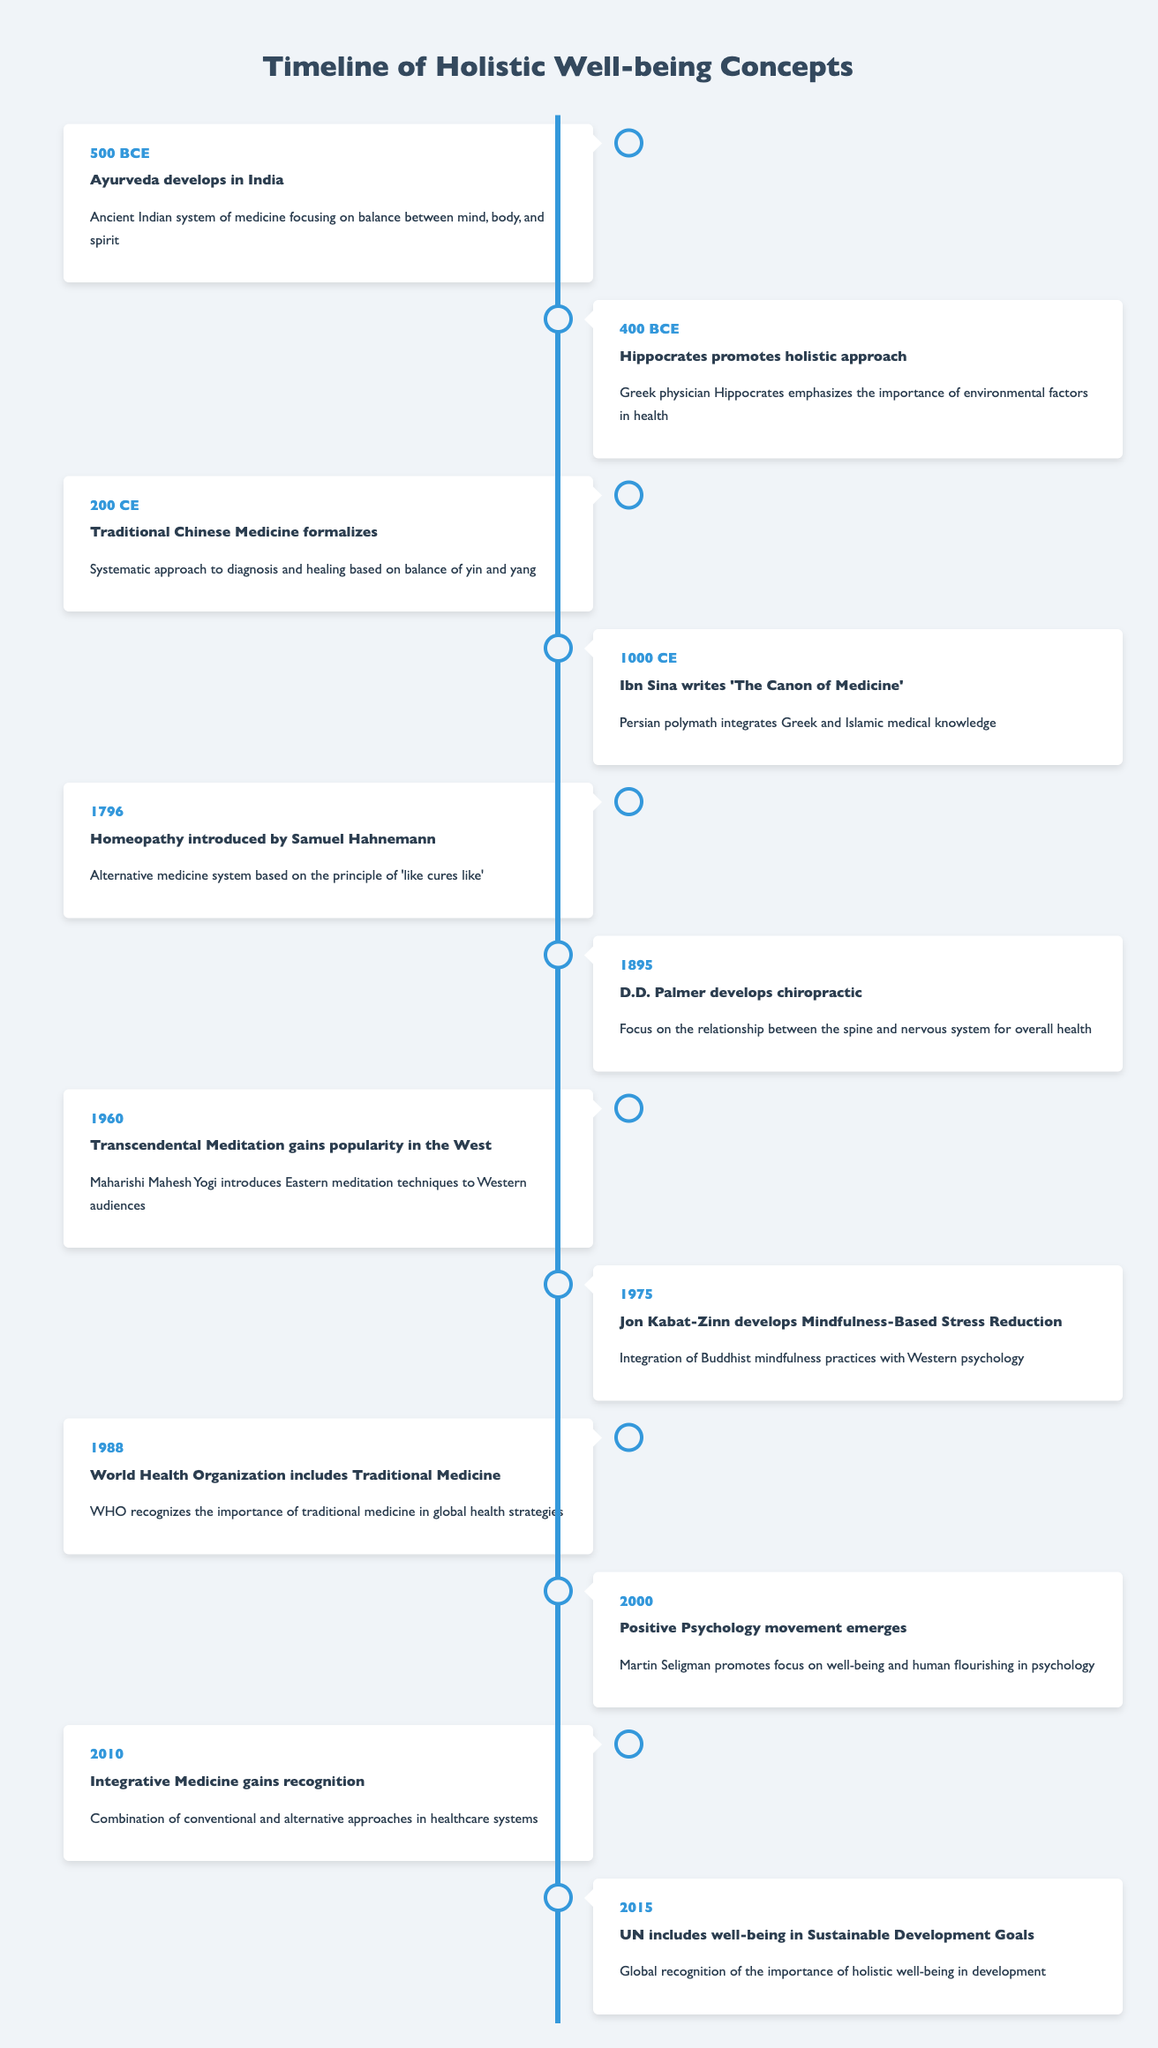What year did Ayurveda develop in India? According to the timeline, Ayurveda developed in India in the year 500 BCE.
Answer: 500 BCE Which philosophy did Hippocrates contribute to in 400 BCE? The timeline states that in 400 BCE, Hippocrates promoted a holistic approach, emphasizing the importance of environmental factors in health.
Answer: Holistic approach What is the event related to Traditional Chinese Medicine? The timeline indicates that Traditional Chinese Medicine was formalized in the year 200 CE.
Answer: 200 CE Which event occurred first: the introduction of Homeopathy or the development of Chiropractic? Homeopathy was introduced in 1796, while Chiropractic was developed in 1895. Since 1796 is earlier than 1895, the event related to Homeopathy occurred first.
Answer: Homeopathy What is the last event listed in the timeline? The last event mentioned in the timeline is the inclusion of well-being in the Sustainable Development Goals by the UN in 2015.
Answer: 2015 In which year did Jon Kabat-Zinn develop Mindfulness-Based Stress Reduction? According to the timeline, Jon Kabat-Zinn developed Mindfulness-Based Stress Reduction in 1975.
Answer: 1975 Is it true that the World Health Organization included Traditional Medicine in 1988? Yes, the timeline confirms that the World Health Organization recognized Traditional Medicine in the year 1988.
Answer: Yes How many years passed between the formalization of Traditional Chinese Medicine and the development of Mindfulness-Based Stress Reduction? Traditional Chinese Medicine was formalized in 200 CE and Mindfulness-Based Stress Reduction was developed in 1975. The difference in years is 1975 - 200 = 1775 years.
Answer: 1775 years Was the Positive Psychology movement active before or after Traditional Medicine was included by the WHO? The WHO included Traditional Medicine in 1988 and the Positive Psychology movement emerged in 2000. Since 2000 is after 1988, the movement was active after the inclusion.
Answer: After 